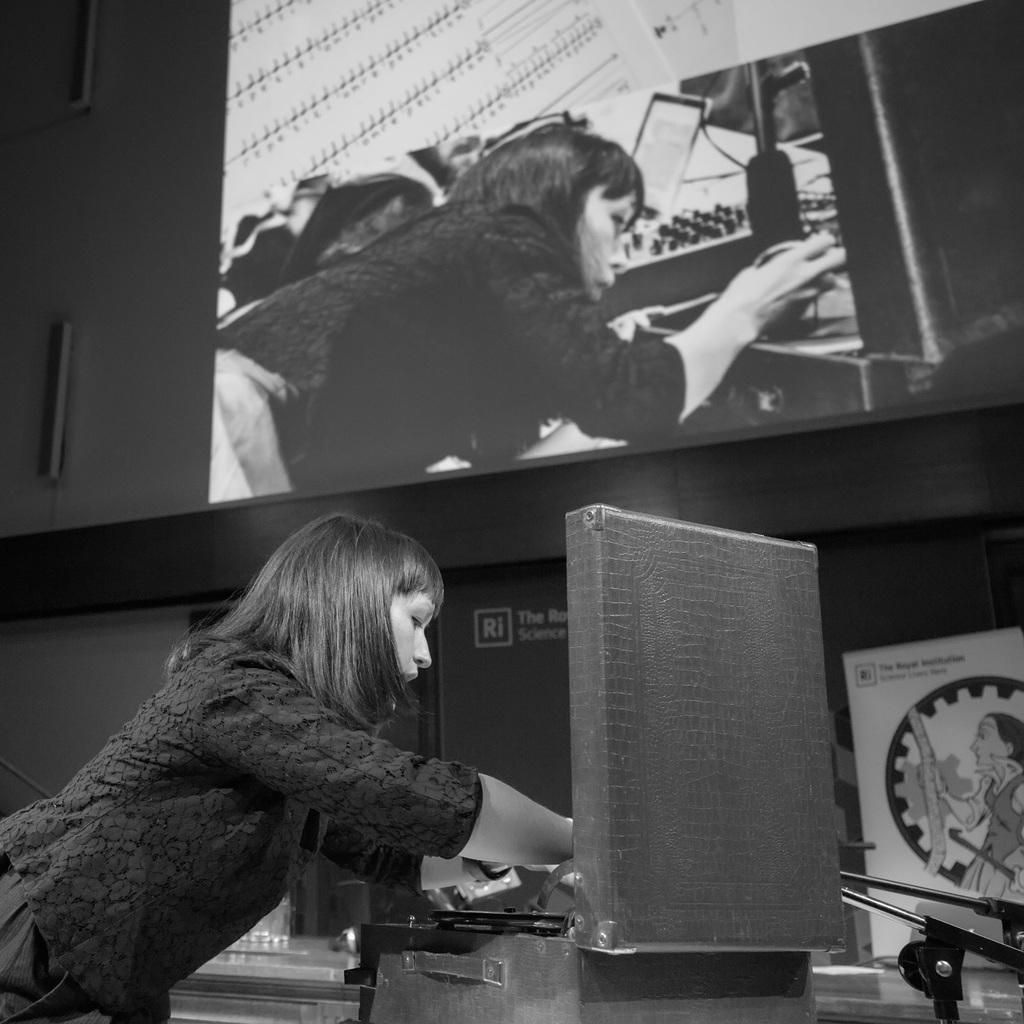Describe this image in one or two sentences. In this picture I can see a woman and looks like she is working on a machine and I can see a poster with some text and a picture on it and It looks like a screen displaying at the top of the picture. 